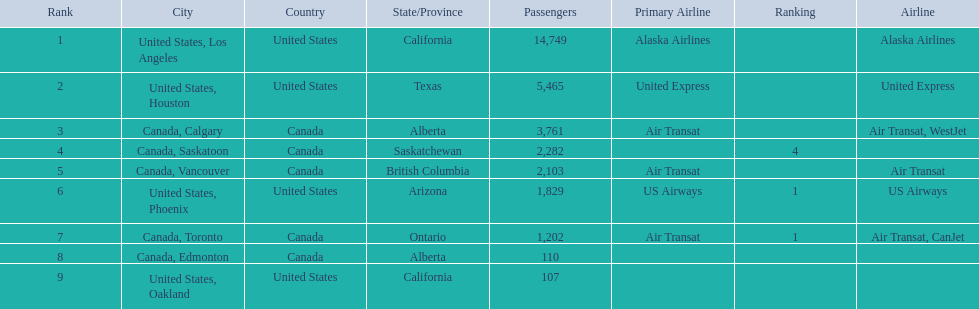Which airport has the least amount of passengers? 107. What airport has 107 passengers? United States, Oakland. 